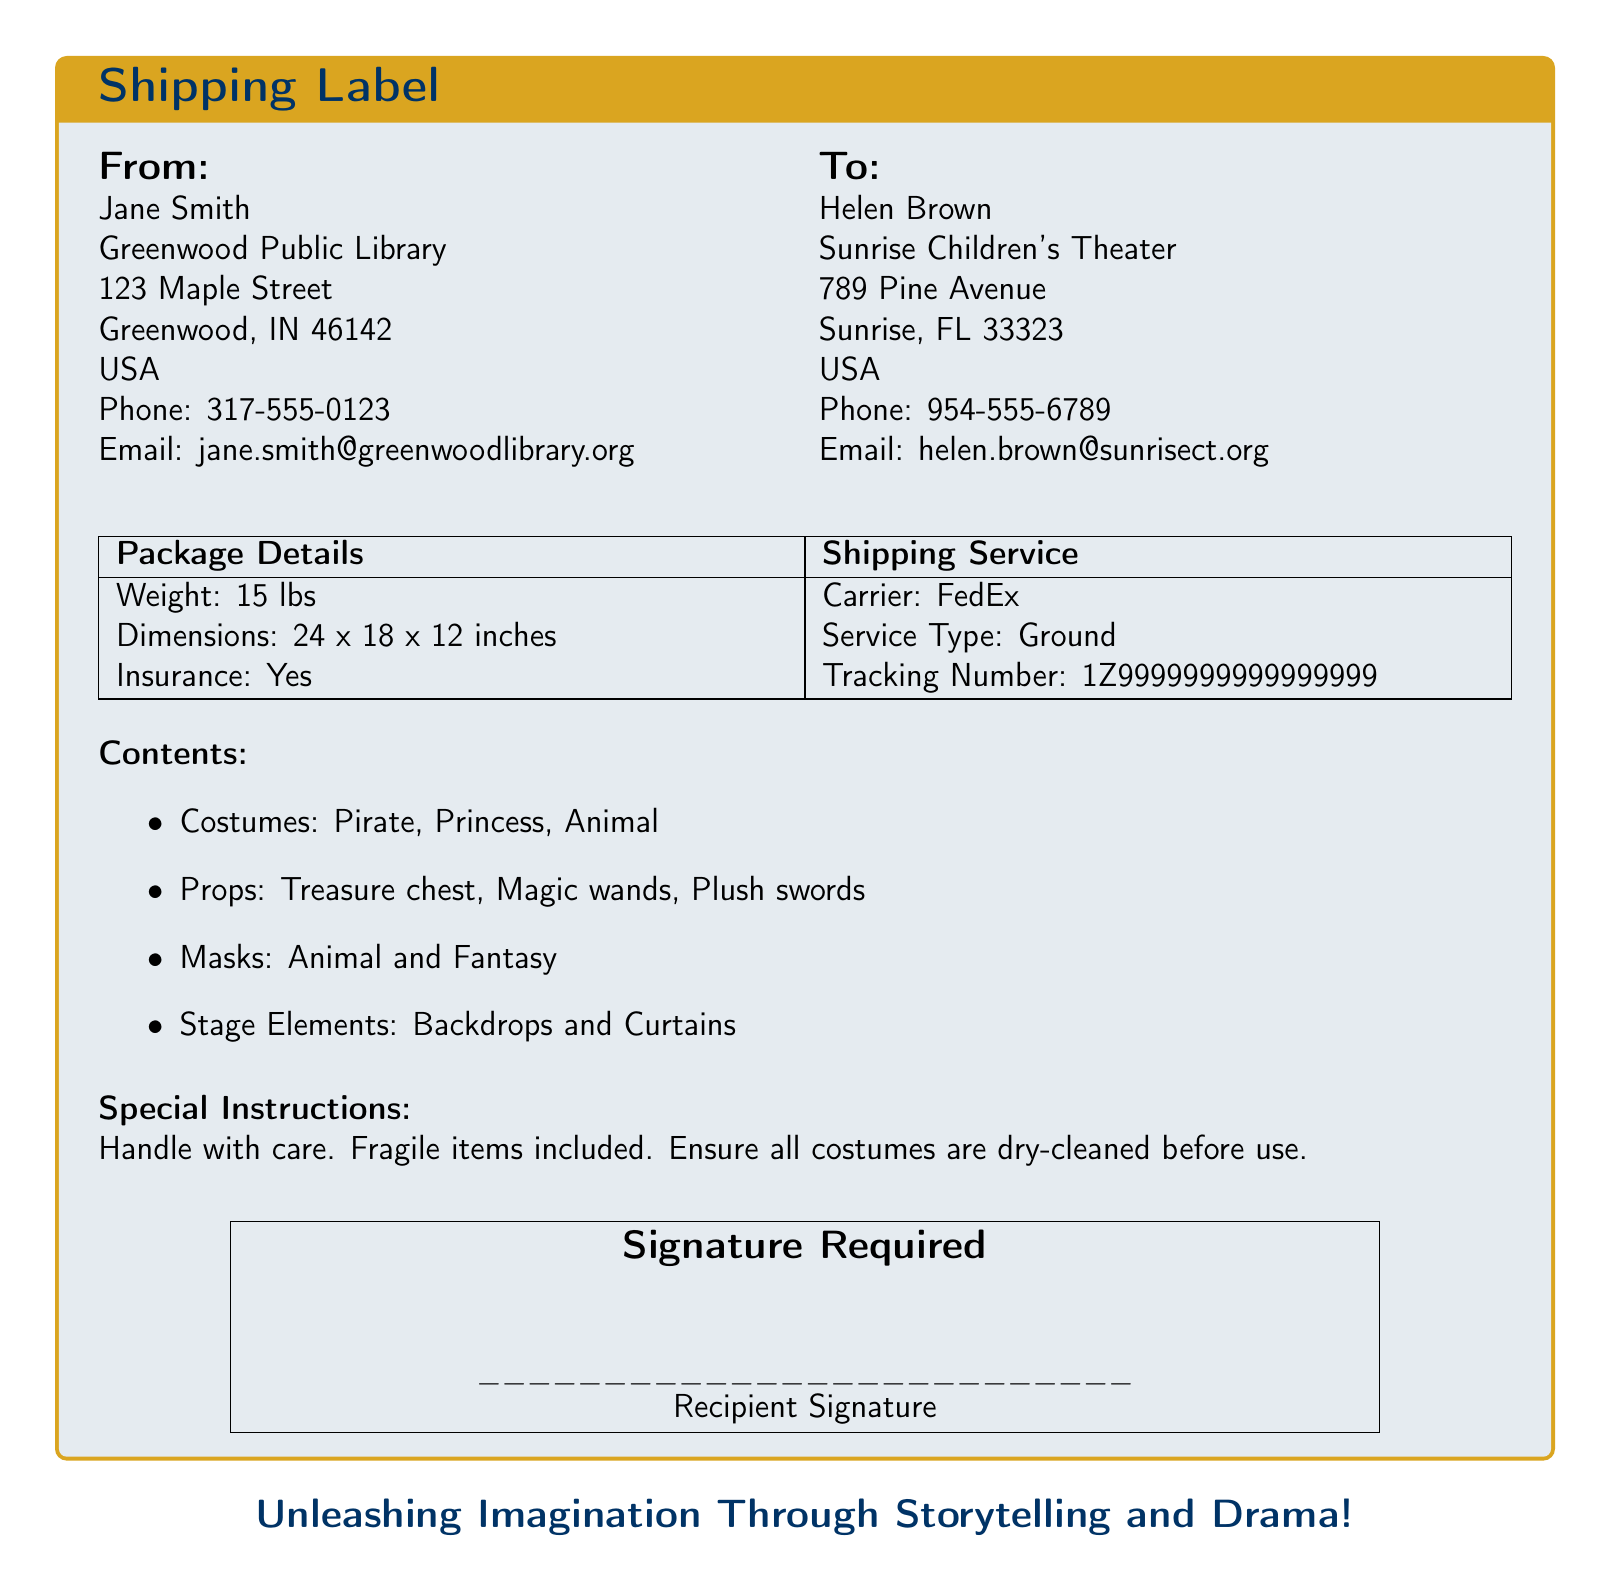What is the name of the sender? The sender's name is Jane Smith, as stated at the top of the shipping label.
Answer: Jane Smith What is the weight of the package? The weight of the package is listed in the package details section of the document.
Answer: 15 lbs What shipping carrier is used? The document specifies the carrier used for shipping the package.
Answer: FedEx What special instructions are provided? The special instructions section contains specific handling instructions for the package.
Answer: Handle with care. Fragile items included What types of costumes are included? The contents list details the types of costumes included in the shipment.
Answer: Pirate, Princess, Animal What is the recipient's email address? The recipient's email address is located under the "To" section of the document.
Answer: helen.brown@sunrisect.org What is the service type for shipping? The service type is mentioned alongside the shipping carrier in the shipping service details.
Answer: Ground How many items are listed under the props section? The props section lists the specific items included in the package, which can be counted.
Answer: 3 What is the tracking number for this shipment? The tracking number for the shipment is indicated in the shipping service section.
Answer: 1Z9999999999999999 